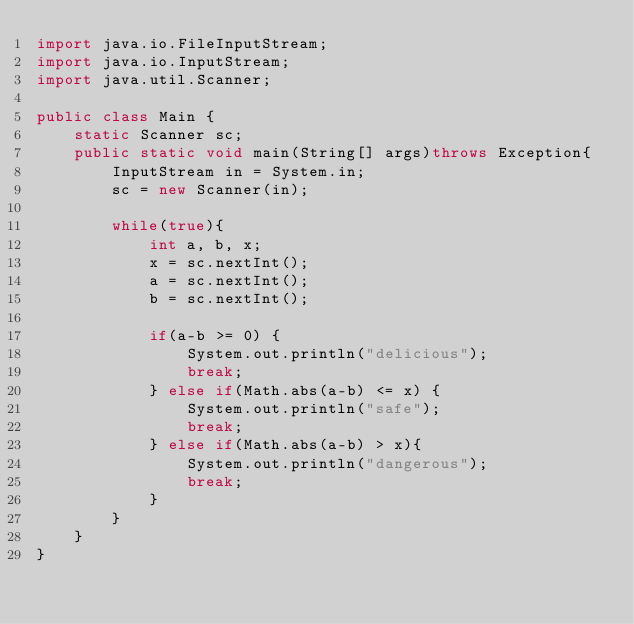Convert code to text. <code><loc_0><loc_0><loc_500><loc_500><_Java_>import java.io.FileInputStream;
import java.io.InputStream;
import java.util.Scanner;

public class Main {
	static Scanner sc;
	public static void main(String[] args)throws Exception{
		InputStream in = System.in;
		sc = new Scanner(in);

		while(true){
			int a, b, x;
			x = sc.nextInt();
			a = sc.nextInt();
			b = sc.nextInt();

			if(a-b >= 0) {
				System.out.println("delicious");
				break;
			} else if(Math.abs(a-b) <= x) {
				System.out.println("safe");
				break;
			} else if(Math.abs(a-b) > x){
				System.out.println("dangerous");
				break;
			}
		}
	}
}
</code> 